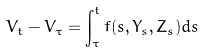Convert formula to latex. <formula><loc_0><loc_0><loc_500><loc_500>V _ { t } - V _ { \tau } = \int _ { \tau } ^ { t } f ( s , Y _ { s } , Z _ { s } ) d s</formula> 